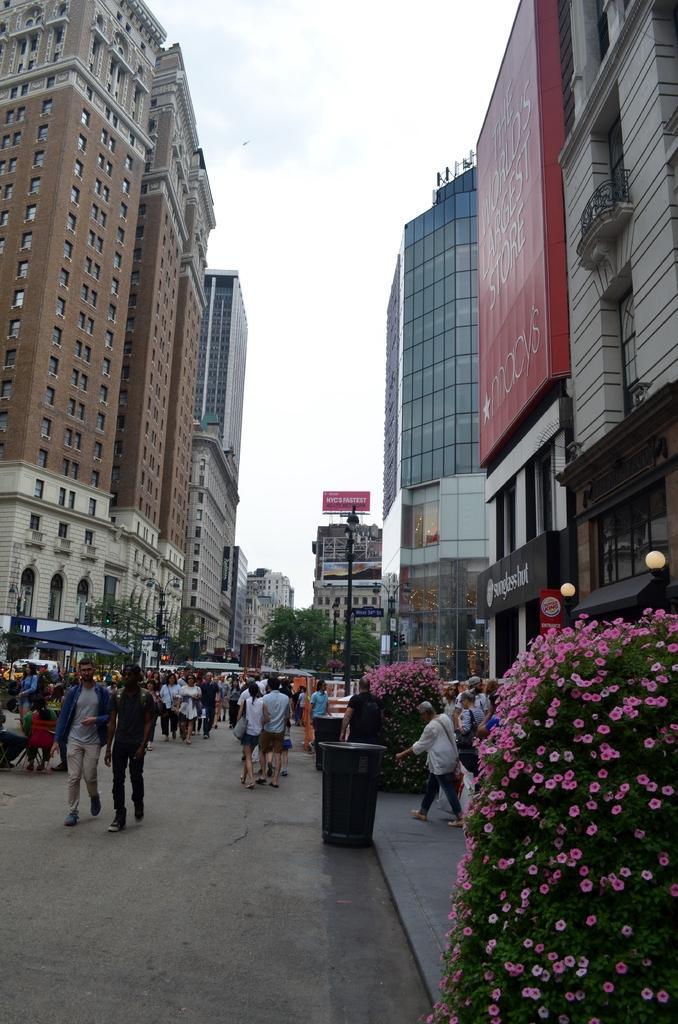Please provide a concise description of this image. In this picture I can see many people were walking on the road. Beside the road I can see the street lights and plants. On the plant I can see some pink color flowers. In the back I can see many buildings and trees. At the top I see the sky and clouds. 